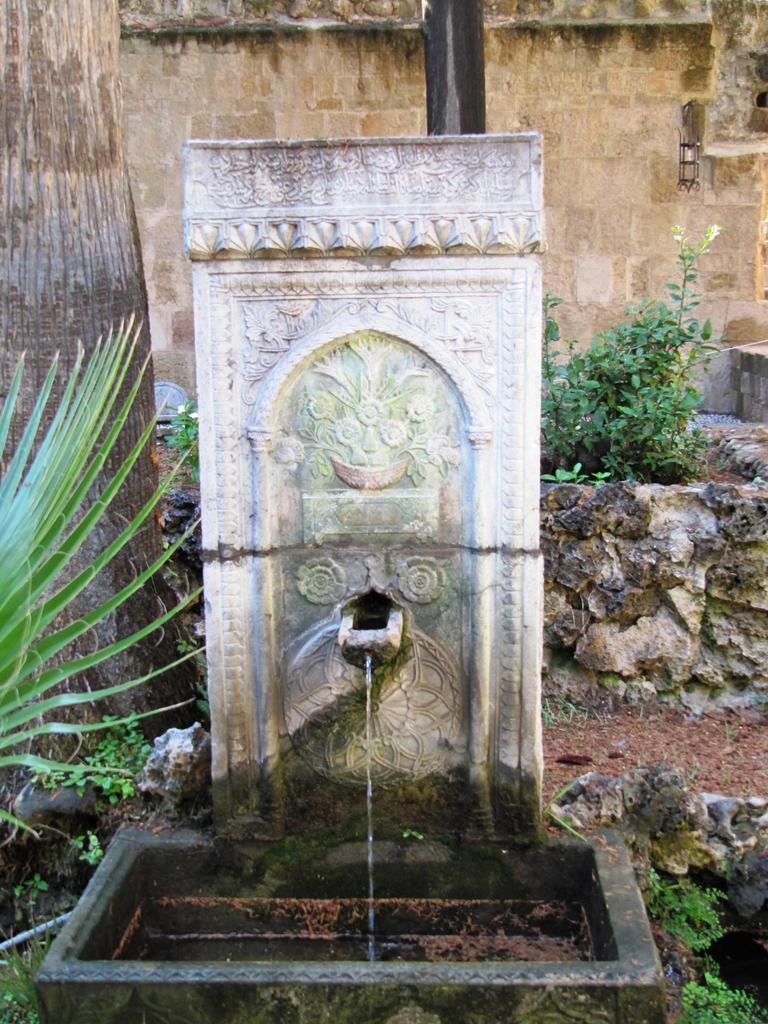How would you summarize this image in a sentence or two? In the background of the image there is wall. To the left side of the image there is a tree trunk. In the center of the image there is a fountain. 